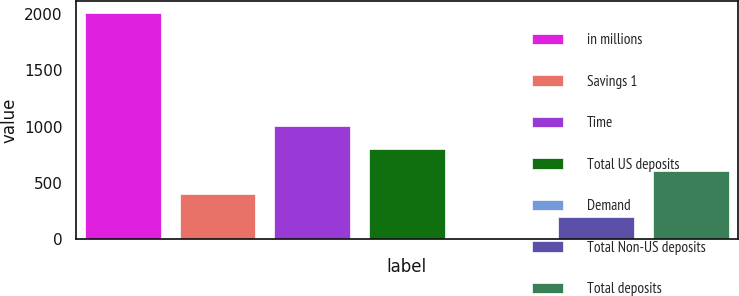Convert chart. <chart><loc_0><loc_0><loc_500><loc_500><bar_chart><fcel>in millions<fcel>Savings 1<fcel>Time<fcel>Total US deposits<fcel>Demand<fcel>Total Non-US deposits<fcel>Total deposits<nl><fcel>2010<fcel>402.28<fcel>1005.19<fcel>804.22<fcel>0.34<fcel>201.31<fcel>603.25<nl></chart> 